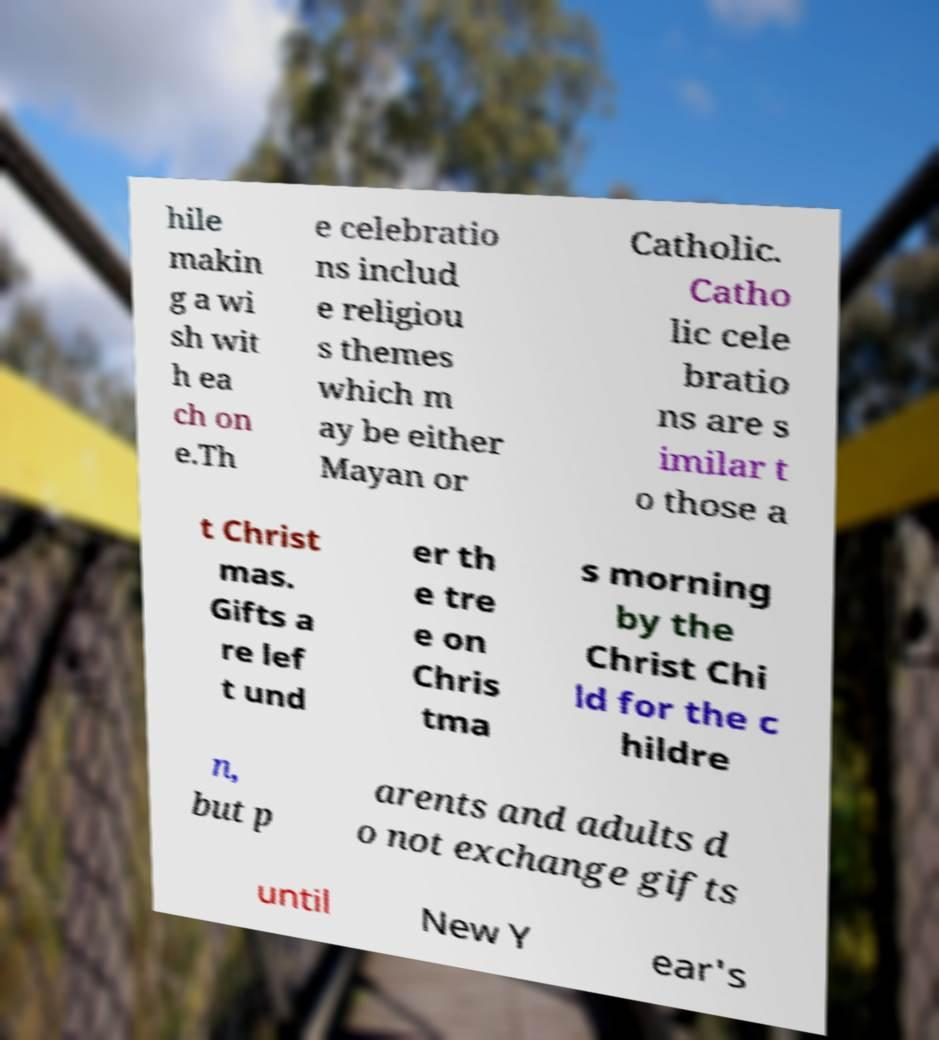Can you read and provide the text displayed in the image?This photo seems to have some interesting text. Can you extract and type it out for me? hile makin g a wi sh wit h ea ch on e.Th e celebratio ns includ e religiou s themes which m ay be either Mayan or Catholic. Catho lic cele bratio ns are s imilar t o those a t Christ mas. Gifts a re lef t und er th e tre e on Chris tma s morning by the Christ Chi ld for the c hildre n, but p arents and adults d o not exchange gifts until New Y ear's 